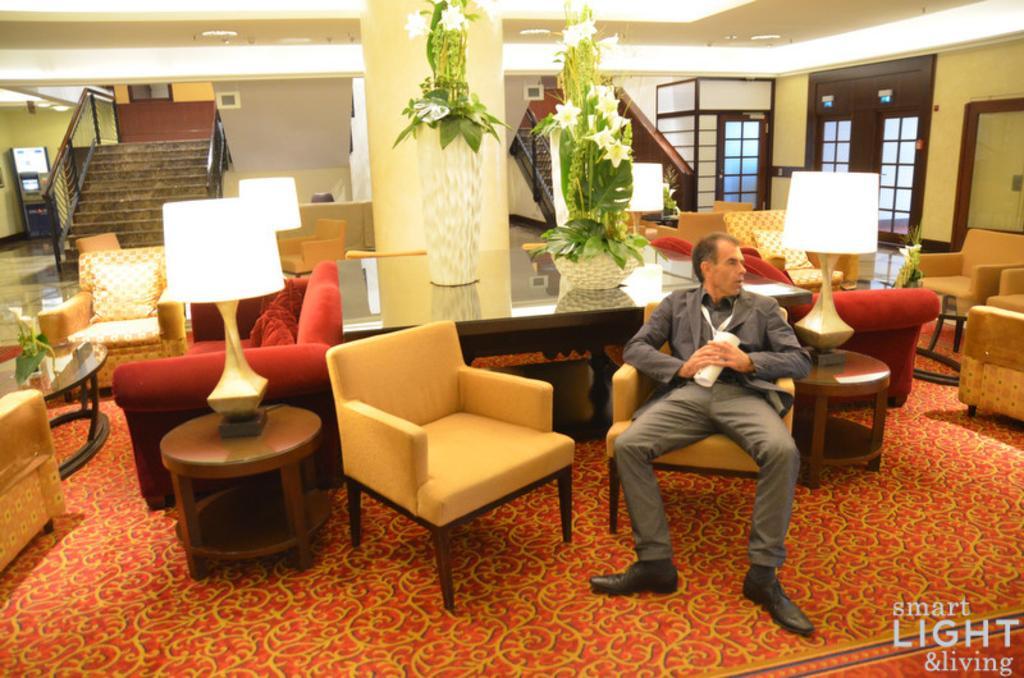Please provide a concise description of this image. In this image there are a group of couches, chairs, lamps and tables are there and in the center there is one pillar. Beside that pillar there is one table on that table there are two flower pots and two plants are there, and on the right side there is one person who is sitting on a chair and on the top there is a ceiling and some lights are there and on the left side there are some stairs and on the right side there is a window. 